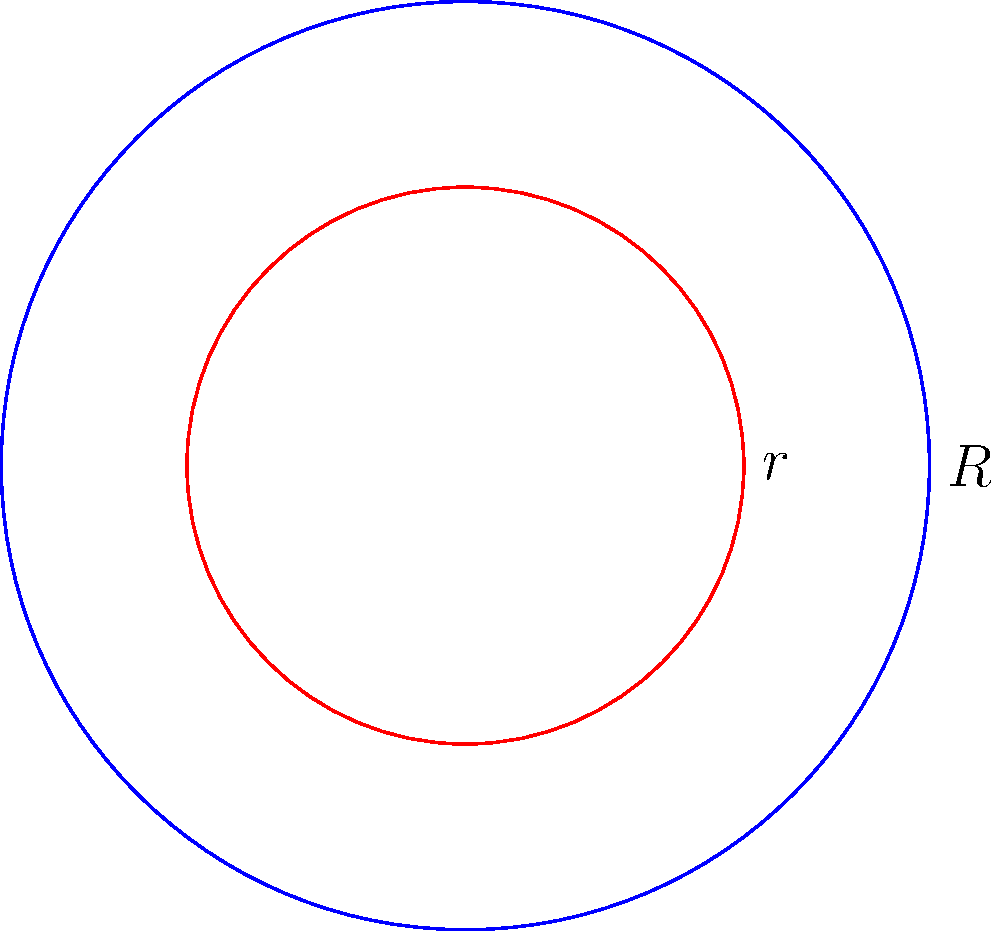As a software engineer optimizing the library's search system, you're working on a feature to calculate the area of circular sections in floor plans. Given two concentric circles with radii $R = 5$ units and $r = 3$ units, determine the area of the region between these circles. Express your answer in terms of $\pi$ square units. To find the area between two concentric circles, we need to:

1. Calculate the area of the larger circle:
   $$A_1 = \pi R^2 = \pi (5^2) = 25\pi$$

2. Calculate the area of the smaller circle:
   $$A_2 = \pi r^2 = \pi (3^2) = 9\pi$$

3. Subtract the area of the smaller circle from the larger circle:
   $$A_{region} = A_1 - A_2 = 25\pi - 9\pi = 16\pi$$

Therefore, the area of the region between the two concentric circles is $16\pi$ square units.
Answer: $16\pi$ square units 